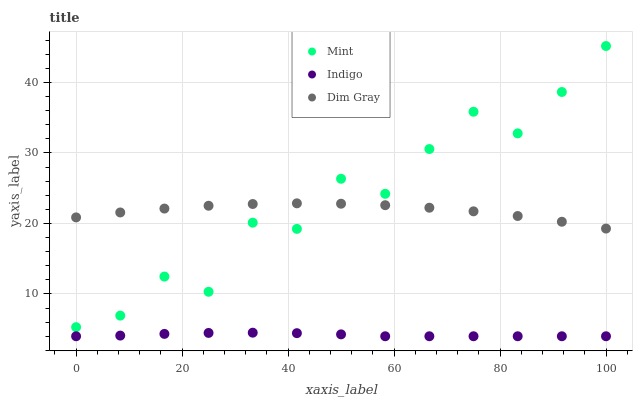Does Indigo have the minimum area under the curve?
Answer yes or no. Yes. Does Mint have the maximum area under the curve?
Answer yes or no. Yes. Does Dim Gray have the minimum area under the curve?
Answer yes or no. No. Does Dim Gray have the maximum area under the curve?
Answer yes or no. No. Is Indigo the smoothest?
Answer yes or no. Yes. Is Mint the roughest?
Answer yes or no. Yes. Is Dim Gray the smoothest?
Answer yes or no. No. Is Dim Gray the roughest?
Answer yes or no. No. Does Indigo have the lowest value?
Answer yes or no. Yes. Does Mint have the lowest value?
Answer yes or no. No. Does Mint have the highest value?
Answer yes or no. Yes. Does Dim Gray have the highest value?
Answer yes or no. No. Is Indigo less than Mint?
Answer yes or no. Yes. Is Mint greater than Indigo?
Answer yes or no. Yes. Does Dim Gray intersect Mint?
Answer yes or no. Yes. Is Dim Gray less than Mint?
Answer yes or no. No. Is Dim Gray greater than Mint?
Answer yes or no. No. Does Indigo intersect Mint?
Answer yes or no. No. 